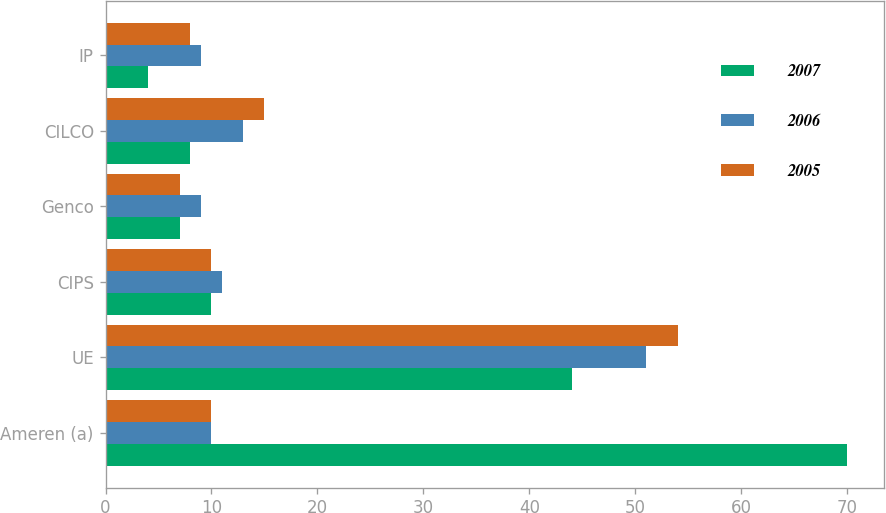Convert chart to OTSL. <chart><loc_0><loc_0><loc_500><loc_500><stacked_bar_chart><ecel><fcel>Ameren (a)<fcel>UE<fcel>CIPS<fcel>Genco<fcel>CILCO<fcel>IP<nl><fcel>2007<fcel>70<fcel>44<fcel>10<fcel>7<fcel>8<fcel>4<nl><fcel>2006<fcel>10<fcel>51<fcel>11<fcel>9<fcel>13<fcel>9<nl><fcel>2005<fcel>10<fcel>54<fcel>10<fcel>7<fcel>15<fcel>8<nl></chart> 